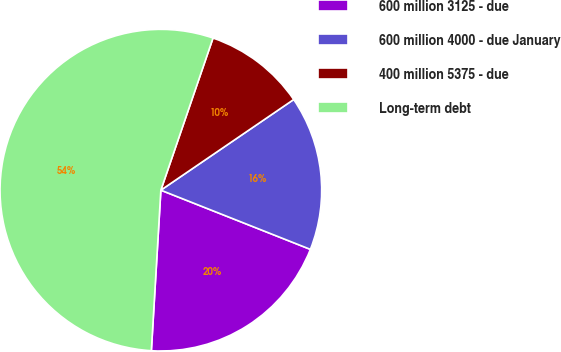<chart> <loc_0><loc_0><loc_500><loc_500><pie_chart><fcel>600 million 3125 - due<fcel>600 million 4000 - due January<fcel>400 million 5375 - due<fcel>Long-term debt<nl><fcel>19.94%<fcel>15.53%<fcel>10.21%<fcel>54.31%<nl></chart> 